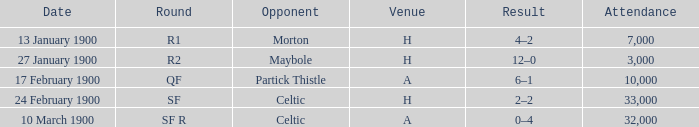How many people attended in the game against morton? 7000.0. 